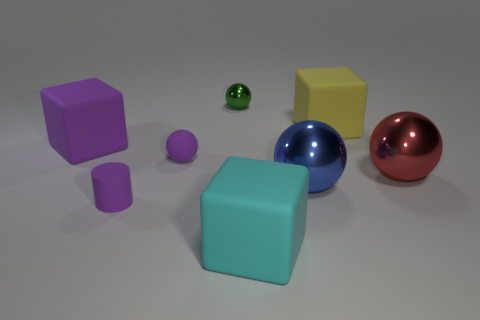What could be the purpose of arranging these objects in this way? The arrangement of these objects seems to be for illustrative purposes, possibly to showcase the rendering capabilities of a 3D modeling software, including textures, lighting, and reflections. It might also be used to teach or assess knowledge of geometry, colors, and spatial relationships. 